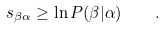Convert formula to latex. <formula><loc_0><loc_0><loc_500><loc_500>s _ { \beta \alpha } \geq \ln P ( \beta | \alpha ) \quad .</formula> 